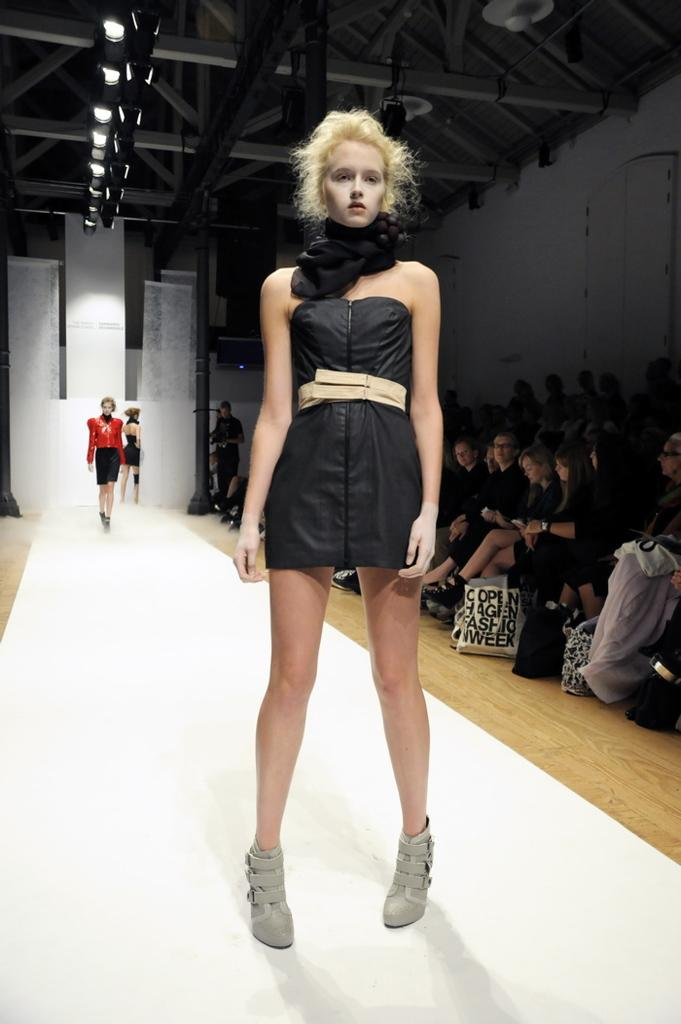What is the person in the foreground of the image doing? The person is standing on the ramp. Can you describe the activity of the two people in the background? The two people in the background are walking on the ramp. What can be seen in the image that provides illumination? Lights are visible in the image. What is the social setting depicted in the image? To produce the conversation, we start by identifying the main subjects and their actions in the image. We then formulate questions that focus on the location and characteristics of these subjects, ensuring that each question can be answered definitively with the information given. We avoid yes/no questions and ensure that the language is simple and clear. Absurd Question/Answer: Is there a dog running through the wilderness in the image? No, there is no dog or wilderness present in the image. Can you see any smoke coming from the chimney in the image? There is no chimney or smoke present in the image. What type of creature is sitting with the group of people in the image? There are no creatures present in the image; only people are depicted. 